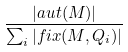<formula> <loc_0><loc_0><loc_500><loc_500>\frac { | a u t ( M ) | } { \sum _ { i } | f i x ( M , Q _ { i } ) | }</formula> 